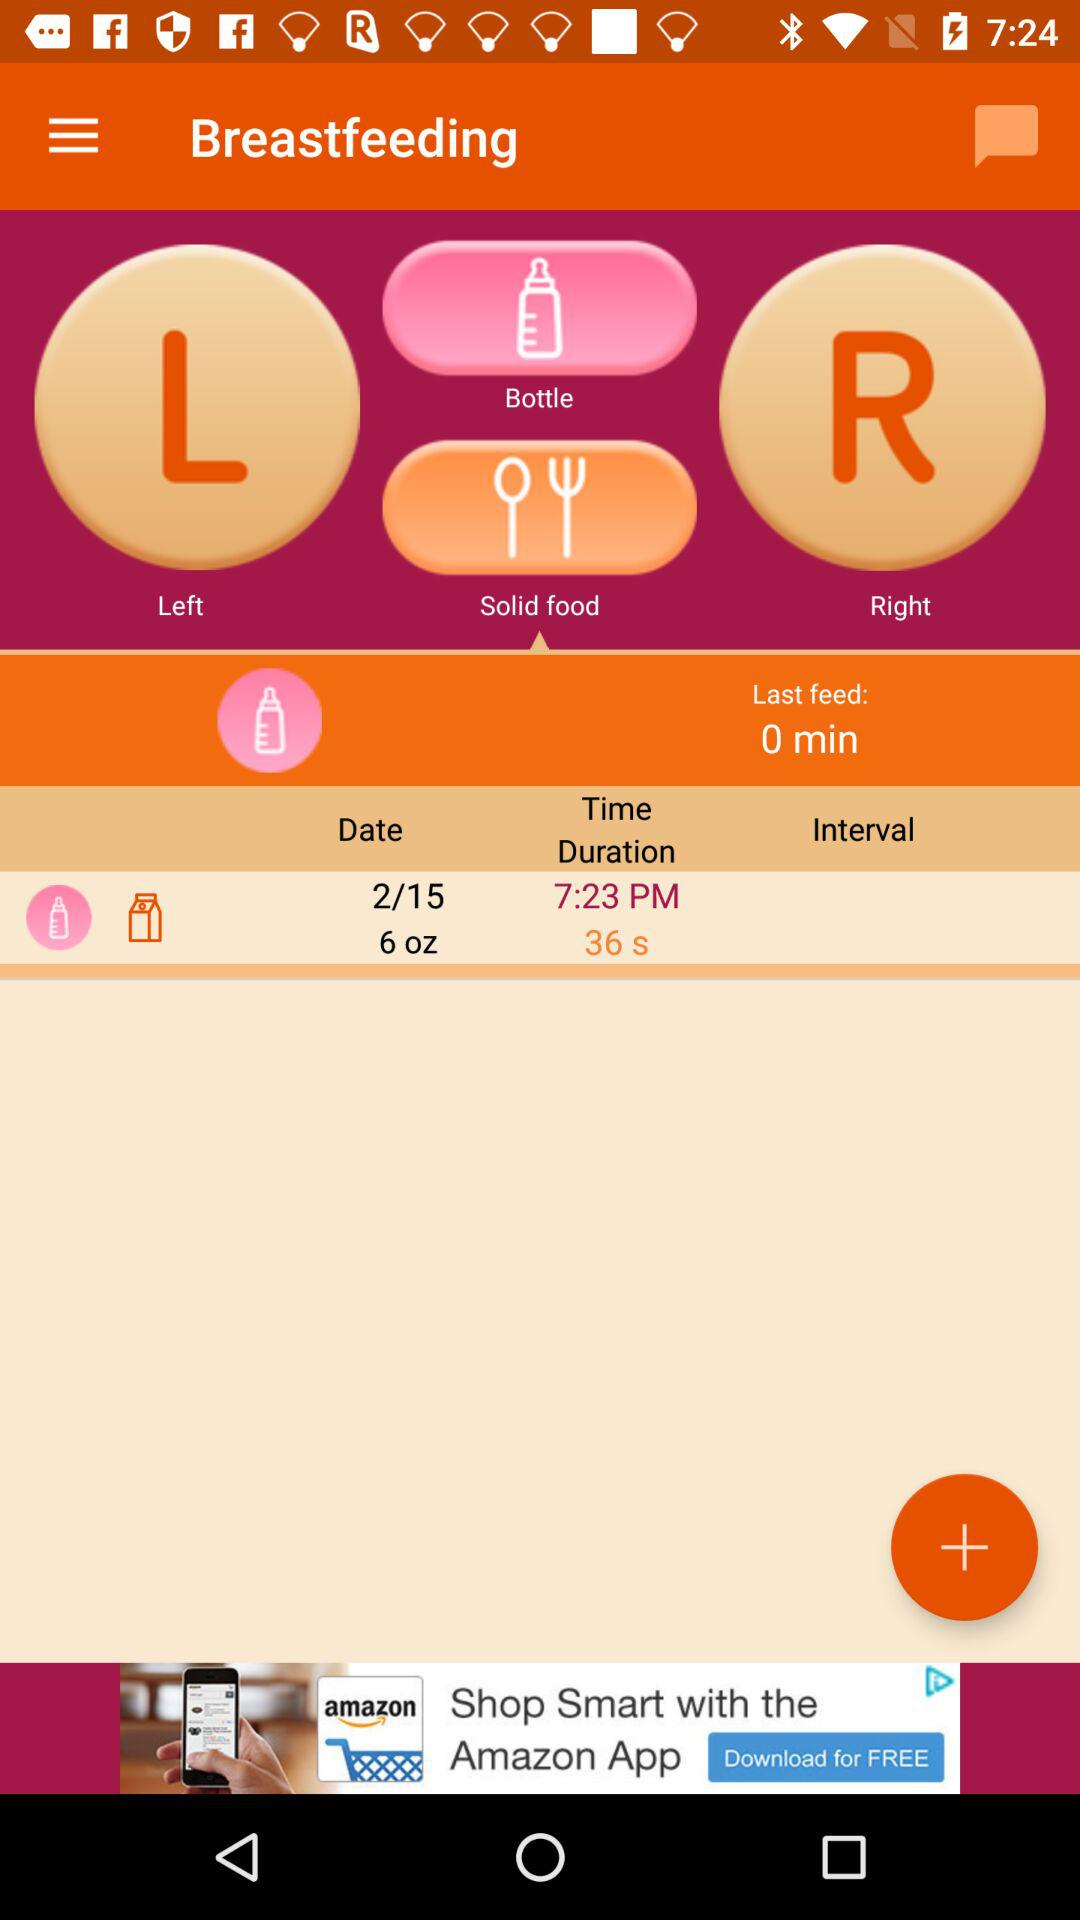What is the time duration? The time duration is 36 seconds. 